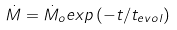Convert formula to latex. <formula><loc_0><loc_0><loc_500><loc_500>\dot { M } = \dot { M } _ { o } e x p \left ( - t / t _ { e v o l } \right )</formula> 